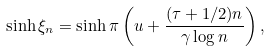<formula> <loc_0><loc_0><loc_500><loc_500>\sinh \xi _ { n } = \sinh \pi \left ( u + \frac { ( \tau + 1 / 2 ) n } { \gamma \log n } \right ) ,</formula> 